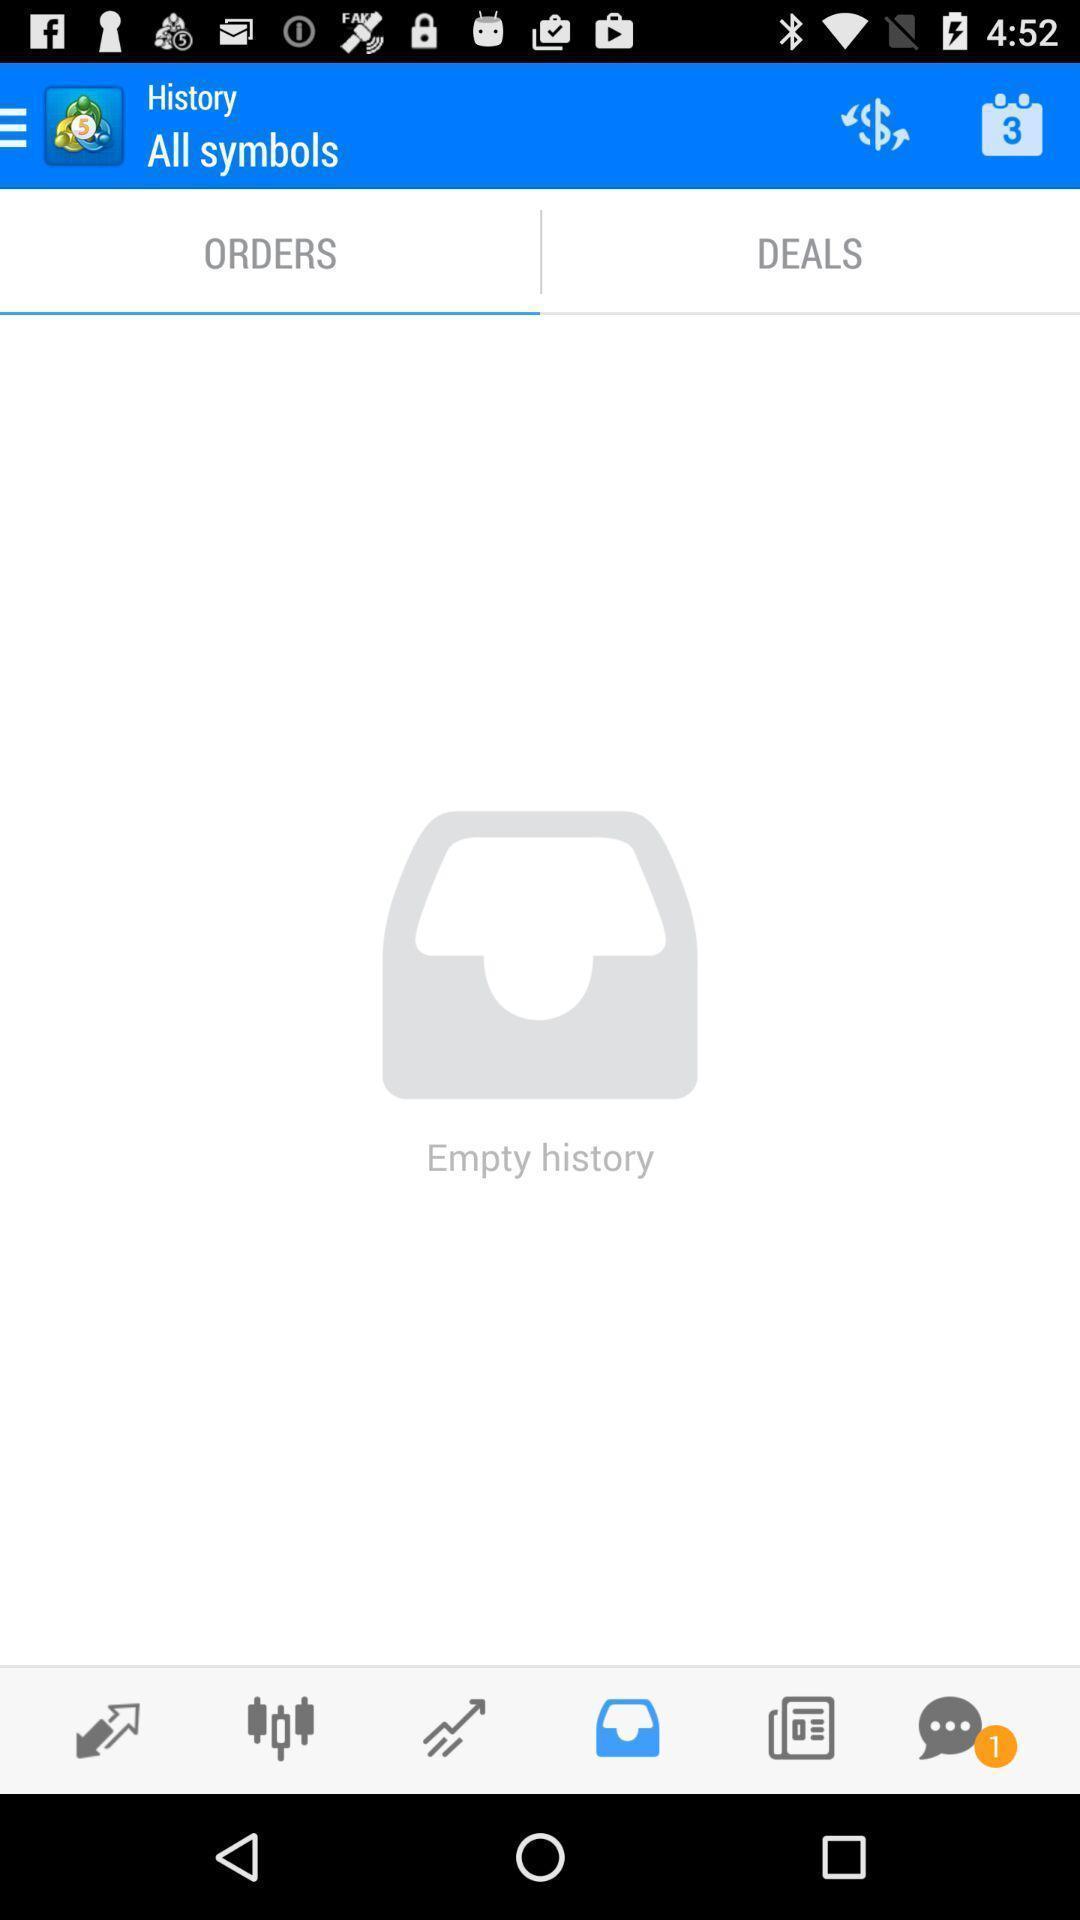Tell me what you see in this picture. Screen showing orders page. 